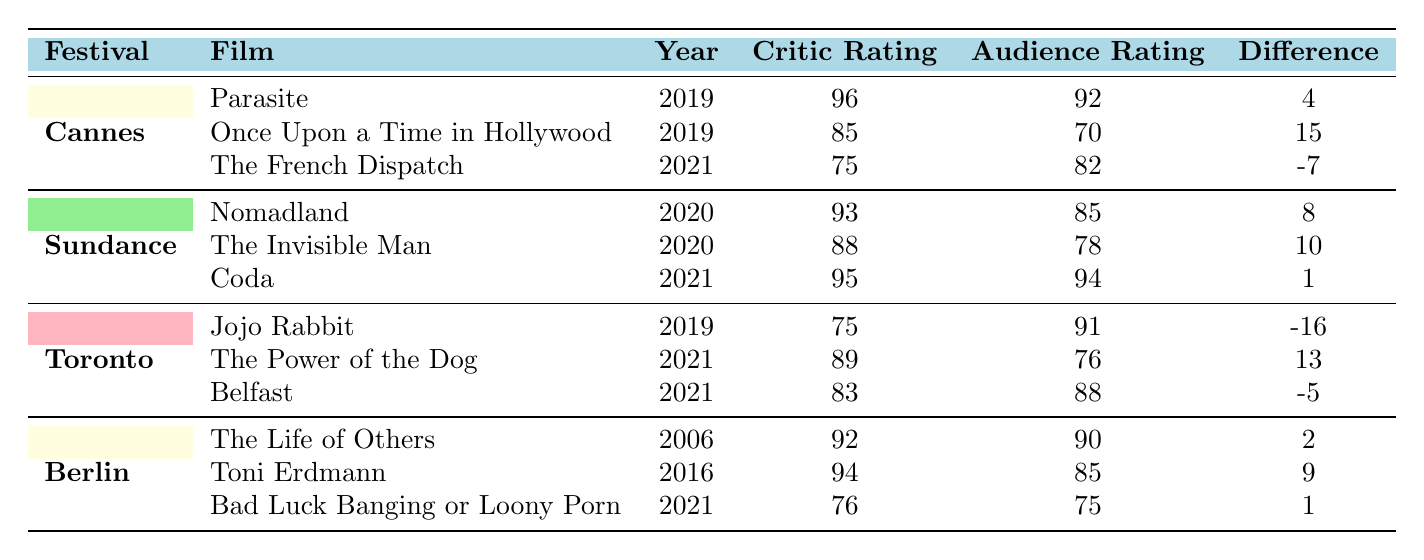What is the Critic Rating of "Coda"? From the Sundance festival section of the table, we locate the film "Coda," which is listed under its films. The Critic Rating for "Coda" is stated as 95.
Answer: 95 Which film has the highest Audience Rating at Cannes? Review the films listed under Cannes festival in the table and look for the Audience Ratings. "Parasite" has an Audience Rating of 92, while "Once Upon a Time in Hollywood" has 70 and "The French Dispatch" has 82. Therefore, "Parasite" has the highest Audience Rating at Cannes.
Answer: Parasite What is the difference between the Critic Rating and Audience Rating for "Once Upon a Time in Hollywood"? For "Once Upon a Time in Hollywood," the Critic Rating is 85 and the Audience Rating is 70. To find the difference, subtract the Audience Rating from the Critic Rating: 85 - 70 = 15.
Answer: 15 Which film at Sundance had the largest gap between Critic Rating and Audience Rating? By examining the films in the Sundance section, we calculate the differences: "Nomadland" has a difference of 8, "The Invisible Man" has 10, and "Coda" has a difference of 1. The largest gap is 10, from "The Invisible Man."
Answer: The Invisible Man Is "Toni Erdmann" rated higher by critics than "Jojo Rabbit"? Checking both films, "Toni Erdmann" has a Critic Rating of 94, while "Jojo Rabbit" has a Critic Rating of 75. Since 94 is greater than 75, we conclude that "Toni Erdmann" is rated higher by critics.
Answer: Yes What is the average Audience Rating for films shown at and including the Toronto festival? First, find the Audience Ratings of the films: "Jojo Rabbit" (91), "The Power of the Dog" (76), and "Belfast" (88). The sum is 91 + 76 + 88 = 255. Then divide by the number of films (3): 255 / 3 = 85.
Answer: 85 For which film is the Critic Rating lower than the Audience Rating at Berlin? Review the Berlin films: "The Life of Others" (Critic 92, Audience 90), "Toni Erdmann" (Critic 94, Audience 85), and "Bad Luck Banging or Loony Porn" (Critic 76, Audience 75). In all these cases, neither film has a Critic Rating lower than the Audience Rating.
Answer: None What is the range of Audience Ratings across all festivals? The highest Audience Rating is 94 ("Coda" at Sundance) and the lowest is 70 ("Once Upon a Time in Hollywood" at Cannes). To find the range, we subtract the lowest from the highest: 94 - 70 = 24.
Answer: 24 Which festival had the film with the lowest Audience Rating? Looking at the Audience Ratings in the table, the lowest rating recorded is 70 for "Once Upon a Time in Hollywood" at Cannes. Thus, Cannes has the film with the lowest Audience Rating.
Answer: Cannes 